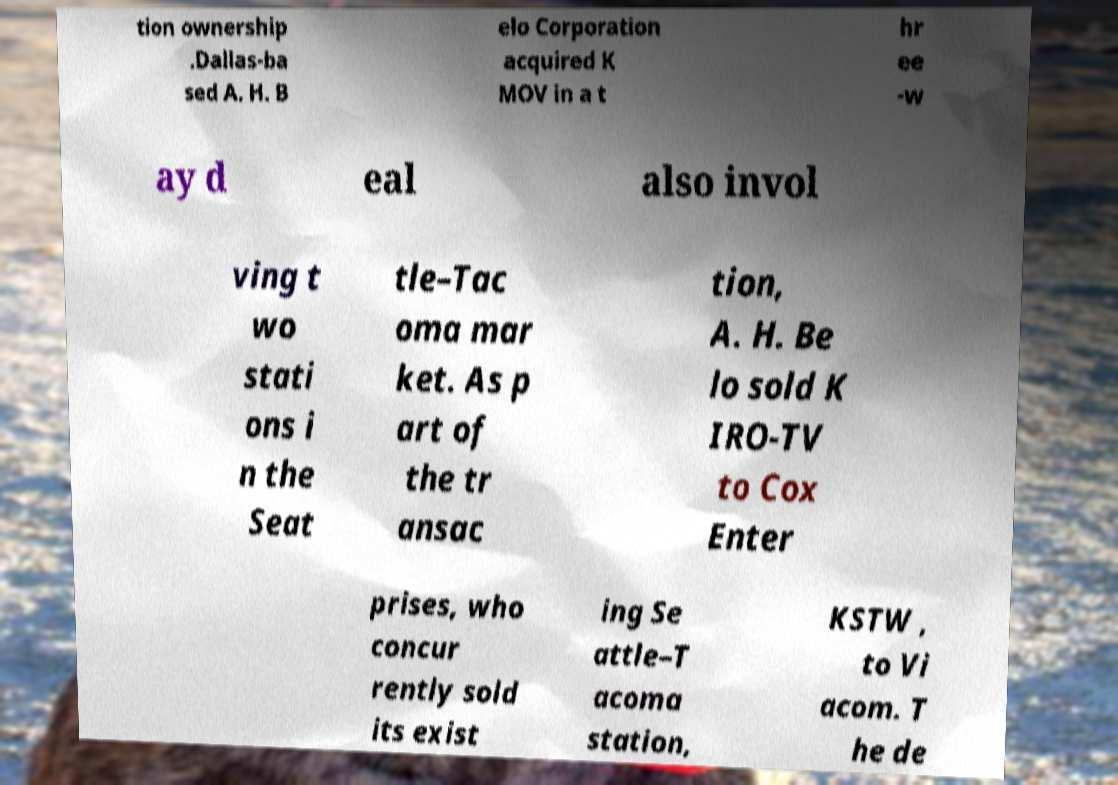Can you accurately transcribe the text from the provided image for me? tion ownership .Dallas-ba sed A. H. B elo Corporation acquired K MOV in a t hr ee -w ay d eal also invol ving t wo stati ons i n the Seat tle–Tac oma mar ket. As p art of the tr ansac tion, A. H. Be lo sold K IRO-TV to Cox Enter prises, who concur rently sold its exist ing Se attle–T acoma station, KSTW , to Vi acom. T he de 